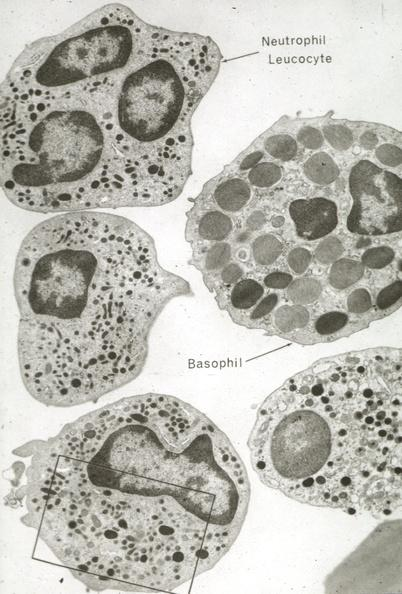what is present?
Answer the question using a single word or phrase. Leukocytes 